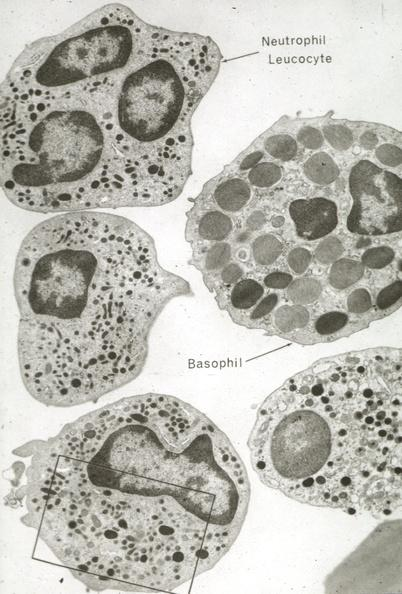what is present?
Answer the question using a single word or phrase. Leukocytes 